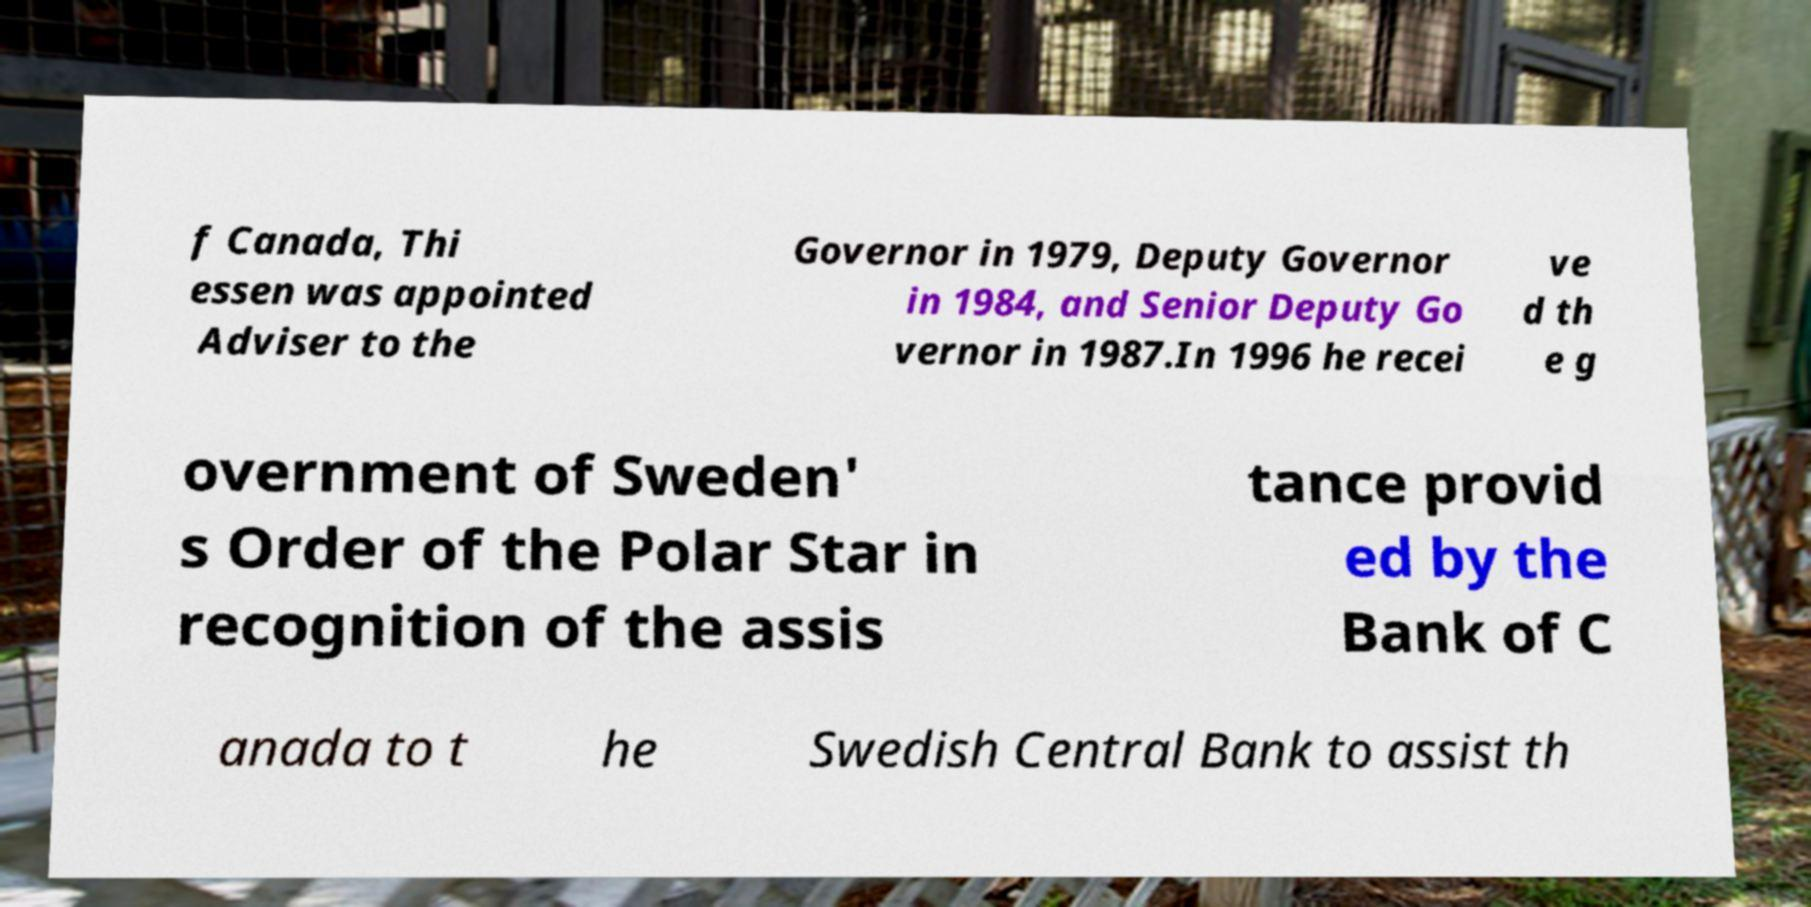Can you read and provide the text displayed in the image?This photo seems to have some interesting text. Can you extract and type it out for me? f Canada, Thi essen was appointed Adviser to the Governor in 1979, Deputy Governor in 1984, and Senior Deputy Go vernor in 1987.In 1996 he recei ve d th e g overnment of Sweden' s Order of the Polar Star in recognition of the assis tance provid ed by the Bank of C anada to t he Swedish Central Bank to assist th 